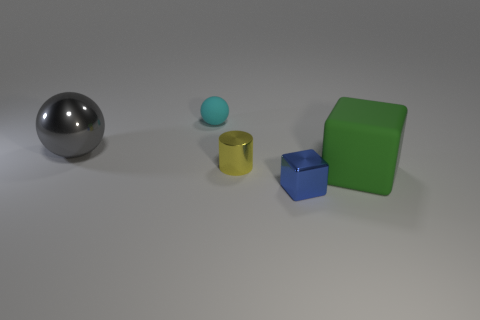Does the gray metallic sphere have the same size as the matte object that is to the left of the shiny block?
Your response must be concise. No. The green block is what size?
Ensure brevity in your answer.  Large. Is the green thing made of the same material as the big object that is behind the cylinder?
Keep it short and to the point. No. There is a green object that is the same size as the gray ball; what is it made of?
Offer a terse response. Rubber. Are there any yellow cylinders that have the same material as the blue thing?
Offer a terse response. Yes. Are there any yellow objects that are in front of the large thing that is left of the matte thing that is to the right of the tiny yellow metallic object?
Your response must be concise. Yes. The cyan rubber thing that is the same size as the yellow metal object is what shape?
Make the answer very short. Sphere. Do the shiny thing that is to the right of the yellow thing and the ball on the left side of the cyan rubber sphere have the same size?
Offer a very short reply. No. What number of big red cylinders are there?
Your response must be concise. 0. There is a cube that is in front of the block behind the block that is in front of the large cube; how big is it?
Offer a very short reply. Small. 